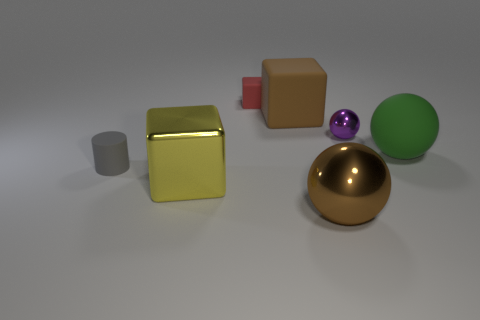Are there any small purple things left of the red rubber cube? Upon examining the image, it appears that there are no small purple items situated to the left of the red cube. The only purple object, which is a small purple sphere, is located to the right of the red cube when viewed from the camera's perspective. 